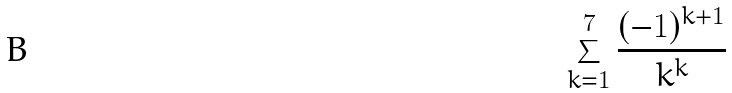Convert formula to latex. <formula><loc_0><loc_0><loc_500><loc_500>\sum _ { k = 1 } ^ { 7 } \frac { ( - 1 ) ^ { k + 1 } } { k ^ { k } }</formula> 